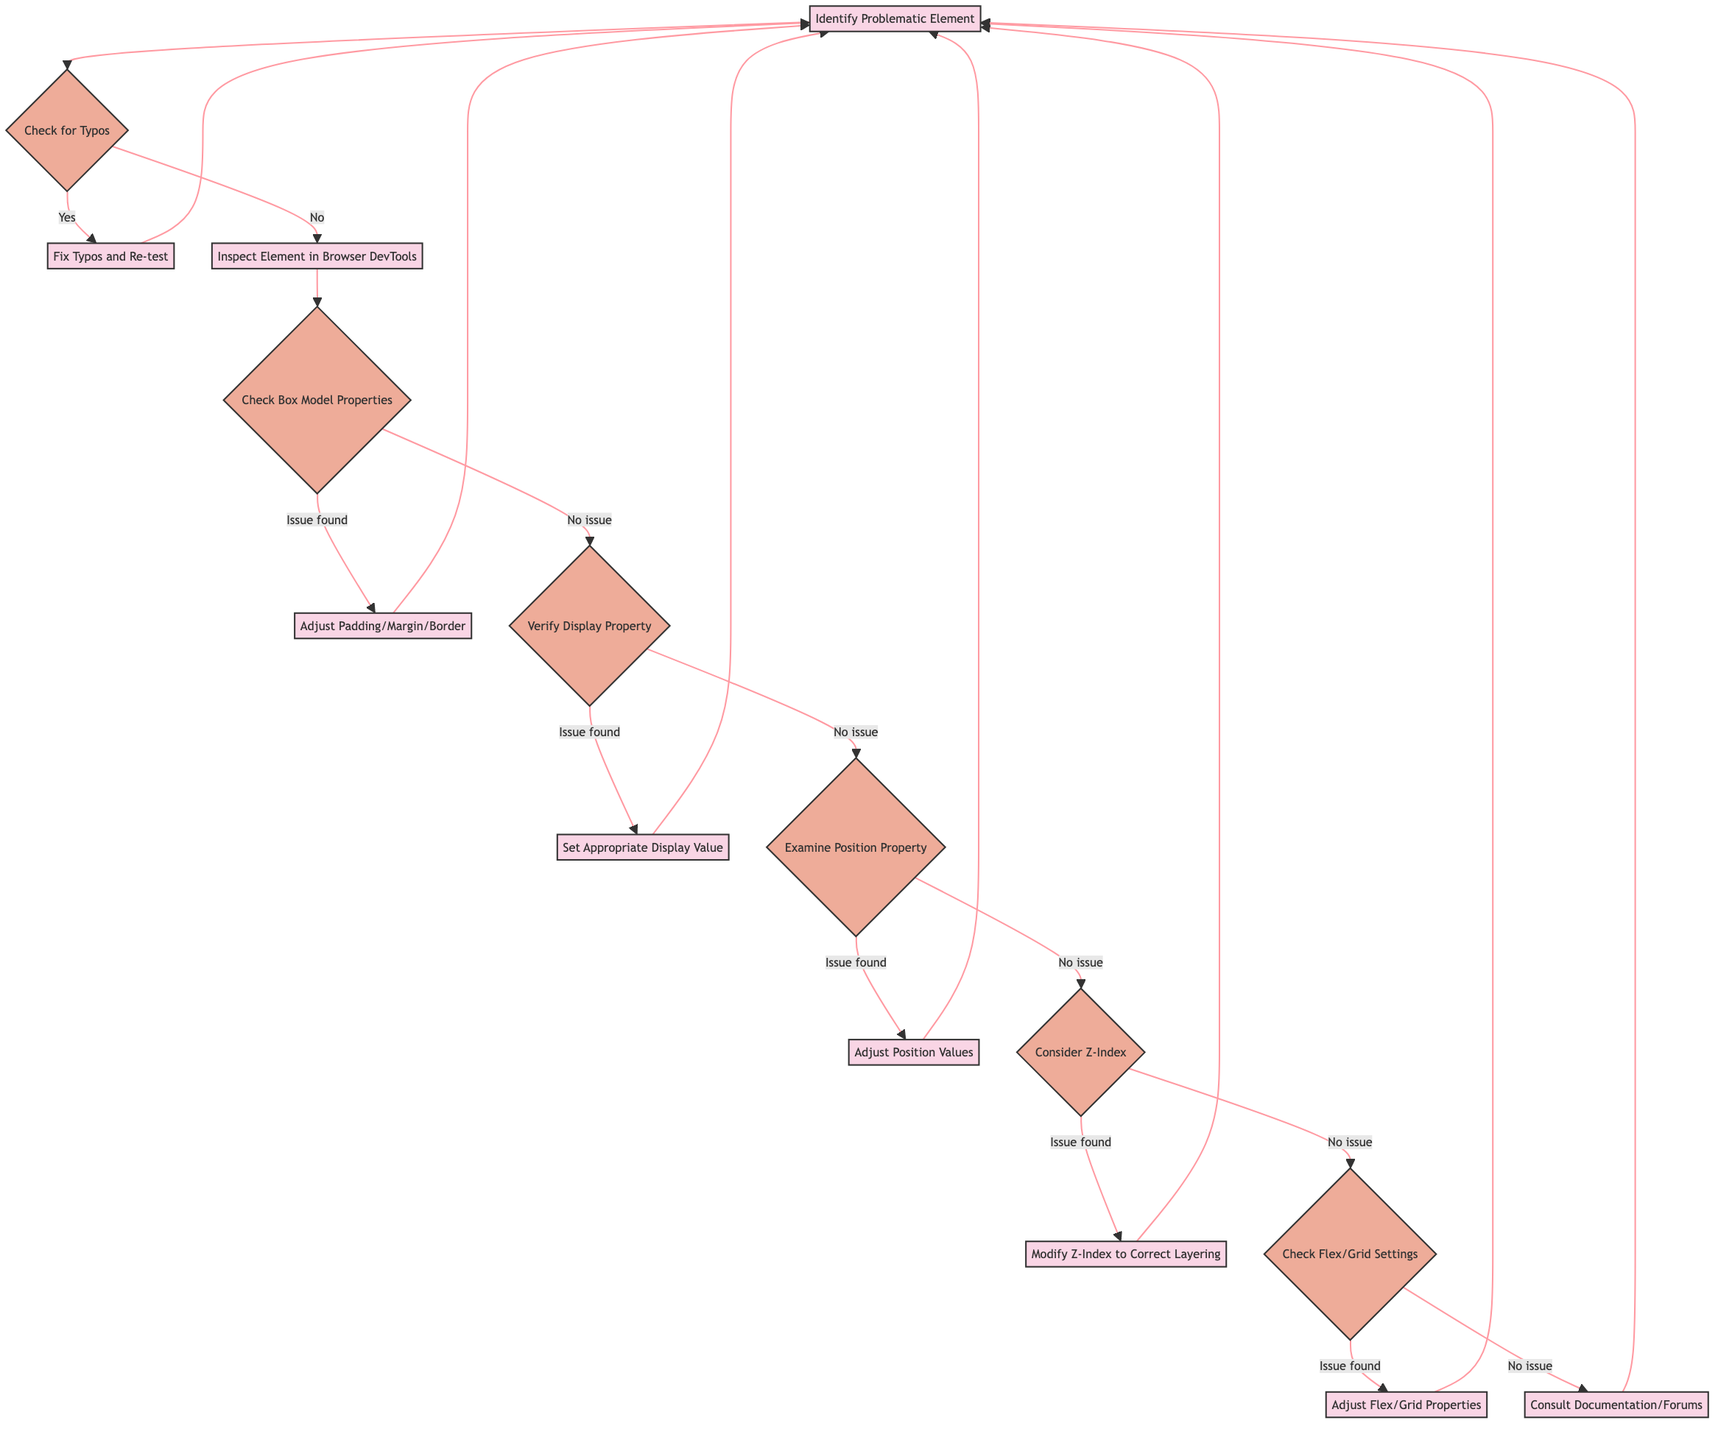What is the first step in the flowchart? The first step in the flowchart, labeled as "1", is the process named "Identify Problematic Element".
Answer: Identify Problematic Element How many decision nodes are present in the diagram? The diagram contains seven decision nodes, which are represented by questions that provide two paths (yes/no or true/false).
Answer: Seven What action follows checking for typos if there are no typos found? If there are no typos found, the next action is to "Inspect Element in Browser DevTools", indicated by node "4".
Answer: Inspect Element in Browser DevTools What occurs after examining the position property if an issue is found? If an issue is found after examining the position property, the next action is to "Adjust Position Values", represented by node "10".
Answer: Adjust Position Values Which action is taken if the box model properties doesn't reveal any issues? If no issue is found with box model properties, the next action is to "Verify Display Property", shown in node "7".
Answer: Verify Display Property What process is repeated after fixing typos? After fixing typos in node "3", the flow returns to the first step, which is again "Identify Problematic Element", indicated by the arrow returning to node "1".
Answer: Identify Problematic Element If a z-index issue is found, which process follows it? If a z-index issue is found, the process that follows is "Modify Z-Index to Correct Layering", indicated by node "12".
Answer: Modify Z-Index to Correct Layering What are the last two processes in the flowchart? The last two processes in the flowchart are "Adjust Flex/Grid Properties" and "Consult Documentation/Forums", represented by nodes "14" and "15".
Answer: Adjust Flex/Grid Properties and Consult Documentation/Forums What is the path taken if the display property is verified with no issues? If the display property has no issues, it leads to examining the position property next, represented by connection from node "9".
Answer: Examine Position Property 